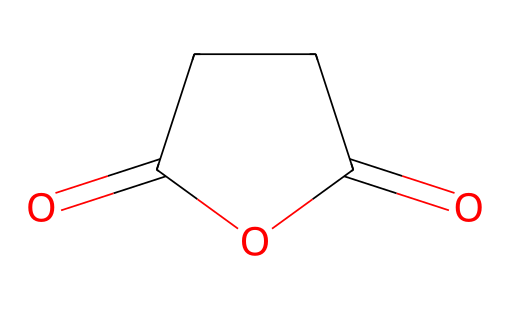What is the molecular formula of succinic anhydride? By interpreting the SMILES representation, the chemical structure shows a six-membered ring which consists of four carbons and two oxygen atoms, confirming the molecular formula as C4H4O3.
Answer: C4H4O3 How many carbon atoms are present in succinic anhydride? Analyzing the structure from the SMILES notation, there are four carbon atoms visible in the cyclic structure of the anhydride.
Answer: 4 What type of functional group is present in succinic anhydride? The presence of a cyclic structure with carbonyl groups indicates that this compound has an anhydride functional group, specifically represented by the two carbonyls adjacent to each other in the ring.
Answer: anhydride How many double bonds are there in succinic anhydride? The SMILES notation features two carbonyl (C=O) groups, accounting for two double bonds in the structure.
Answer: 2 What is the main application of succinic anhydride in biodegradable polymers? Succinic anhydride is often used as a building block in the synthesis of biodegradable polymers due to its reactive anhydride group which can facilitate polymerization and crosslinking.
Answer: building block What is the total number of rings in the structure of succinic anhydride? The SMILES notation demonstrates that there is one cyclic structure formed in the compound, as indicated by the numbering which denotes a ring.
Answer: 1 